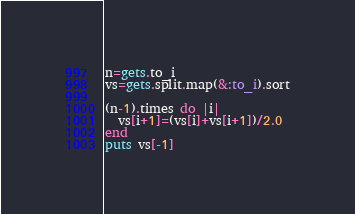Convert code to text. <code><loc_0><loc_0><loc_500><loc_500><_Ruby_>n=gets.to_i
vs=gets.split.map(&:to_i).sort

(n-1).times do |i|
  vs[i+1]=(vs[i]+vs[i+1])/2.0
end
puts vs[-1]
</code> 